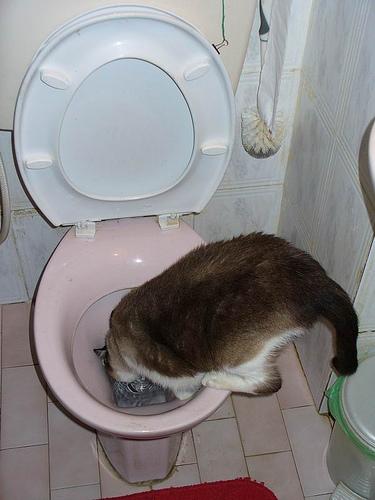What color is the toilet bowl?
Be succinct. Pink. Is the cat drinking from an appropriate container?
Give a very brief answer. No. What is the red thing in front of the toilet?
Quick response, please. Rug. 